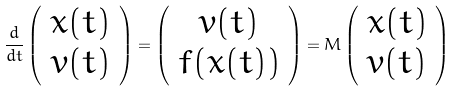Convert formula to latex. <formula><loc_0><loc_0><loc_500><loc_500>\frac { d } { d t } \left ( \begin{array} { c } x ( t ) \\ v ( t ) \end{array} \right ) = \left ( \begin{array} { c } v ( t ) \\ f ( x ( t ) ) \end{array} \right ) = M \left ( \begin{array} { c } x ( t ) \\ v ( t ) \end{array} \right )</formula> 